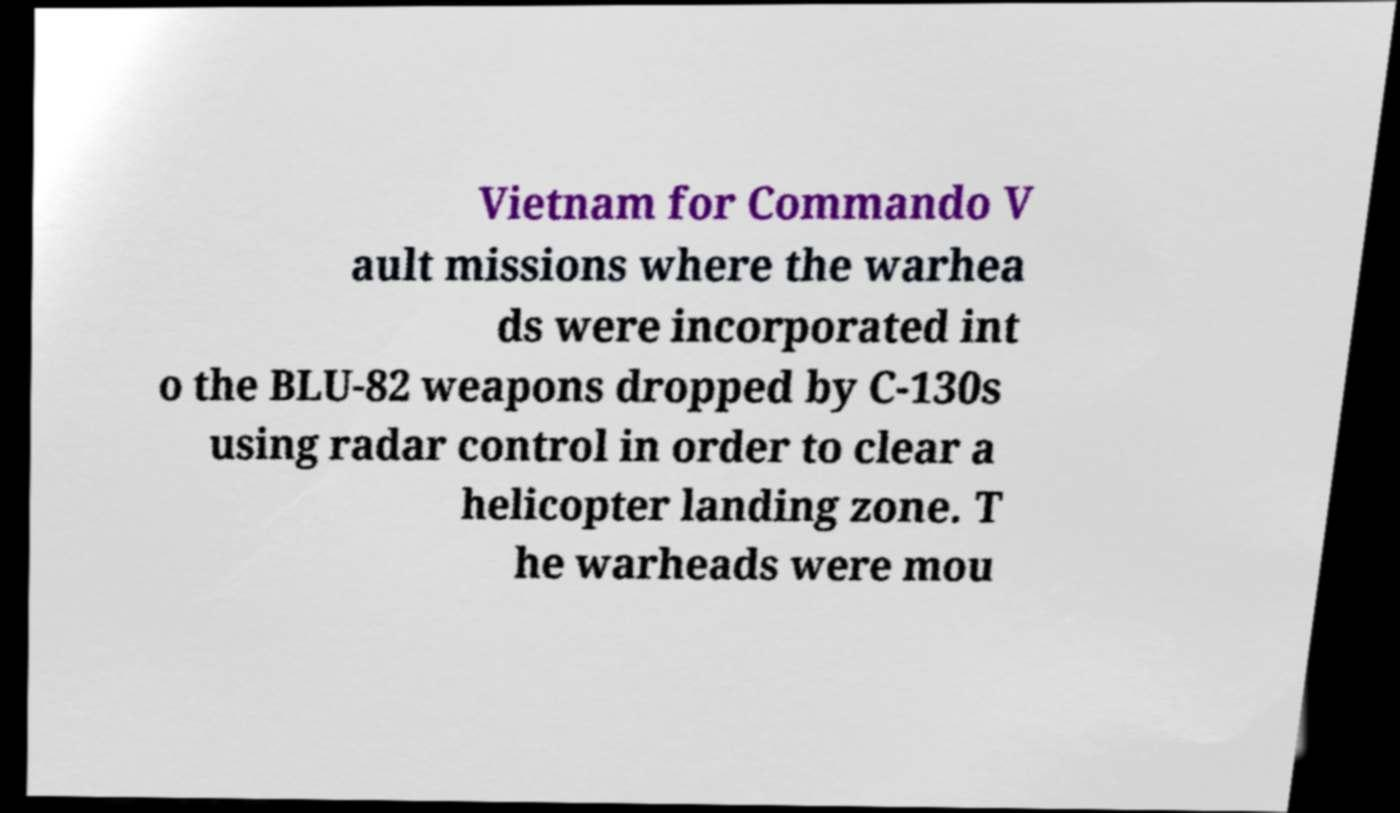Could you extract and type out the text from this image? Vietnam for Commando V ault missions where the warhea ds were incorporated int o the BLU-82 weapons dropped by C-130s using radar control in order to clear a helicopter landing zone. T he warheads were mou 